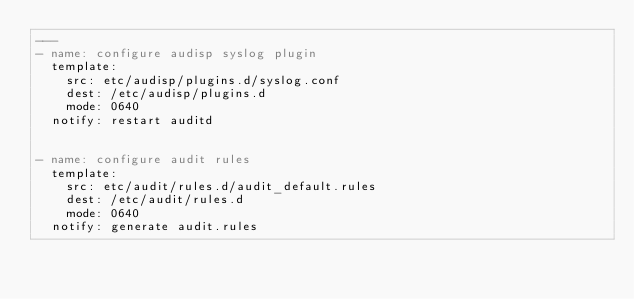Convert code to text. <code><loc_0><loc_0><loc_500><loc_500><_YAML_>---
- name: configure audisp syslog plugin
  template:
    src: etc/audisp/plugins.d/syslog.conf
    dest: /etc/audisp/plugins.d
    mode: 0640
  notify: restart auditd


- name: configure audit rules
  template:
    src: etc/audit/rules.d/audit_default.rules
    dest: /etc/audit/rules.d
    mode: 0640
  notify: generate audit.rules
</code> 